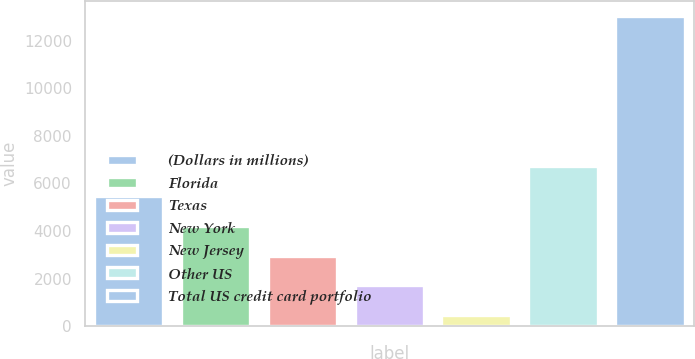Convert chart to OTSL. <chart><loc_0><loc_0><loc_500><loc_500><bar_chart><fcel>(Dollars in millions)<fcel>Florida<fcel>Texas<fcel>New York<fcel>New Jersey<fcel>Other US<fcel>Total US credit card portfolio<nl><fcel>5482<fcel>4224.5<fcel>2967<fcel>1709.5<fcel>452<fcel>6739.5<fcel>13027<nl></chart> 